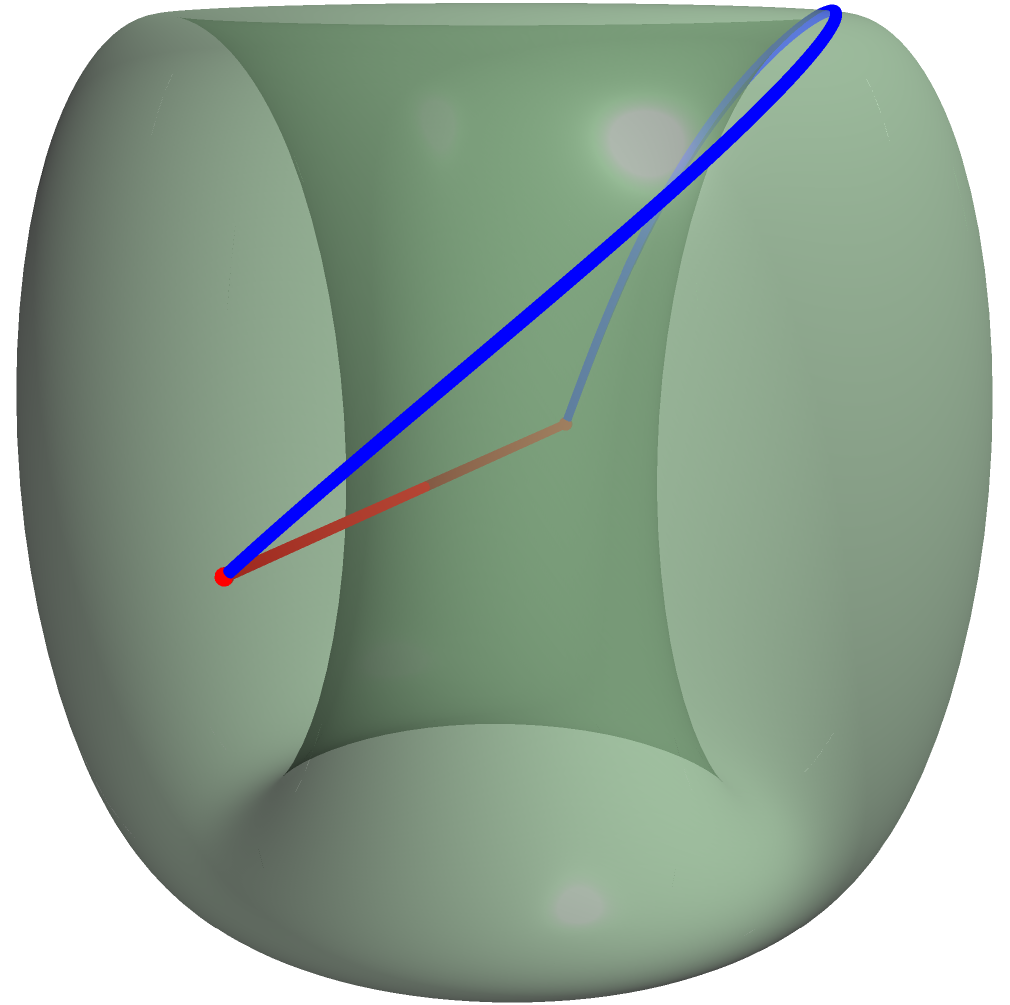In the midst of conflict, you find solace in studying the geometry of your village's ancient artifacts. One such artifact is a torus-shaped object. Two points, A and B, are marked on opposite sides of the torus. The red line represents the direct path between A and B, while the blue curve shows an alternative route. Which path is actually shorter on the surface of the torus, and why is this significant in understanding the nature of curved spaces? To understand this problem, let's break it down step-by-step:

1) In Euclidean geometry, the shortest distance between two points is always a straight line. However, on curved surfaces like a torus, this is not always true.

2) The red line in the diagram represents the direct path between points A and B. This would be the shortest path in flat space.

3) The blue curve represents a geodesic on the surface of the torus. A geodesic is the curved equivalent of a straight line on a curved surface.

4) On a torus, the shortest path between two points is not always the most direct route. The geodesic (blue curve) wraps around the torus in a way that minimizes the distance traveled on the surface.

5) The blue geodesic is actually shorter than the red direct path, despite appearing longer in our 3D visualization. This is because the red line cuts through the torus, while the blue line follows the curvature of the surface.

6) This concept is crucial in non-Euclidean geometry and has practical applications in navigation, physics, and even in understanding the nature of spacetime in general relativity.

7) In the context of the village conflict, this principle could symbolize how the path to peace might not always be the most direct or obvious route, but rather one that follows the contours of the complex situation at hand.
Answer: The blue geodesic curve is shorter on the torus surface, illustrating that the shortest path in curved spaces may not be the most direct. 